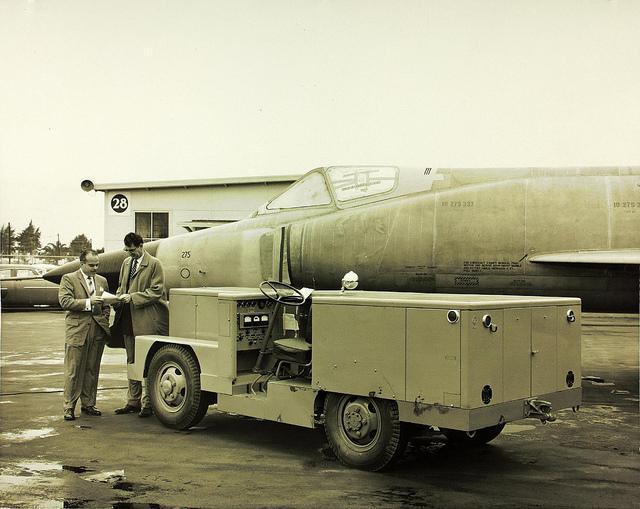How many men are there?
Give a very brief answer. 2. How many people are there?
Give a very brief answer. 2. 